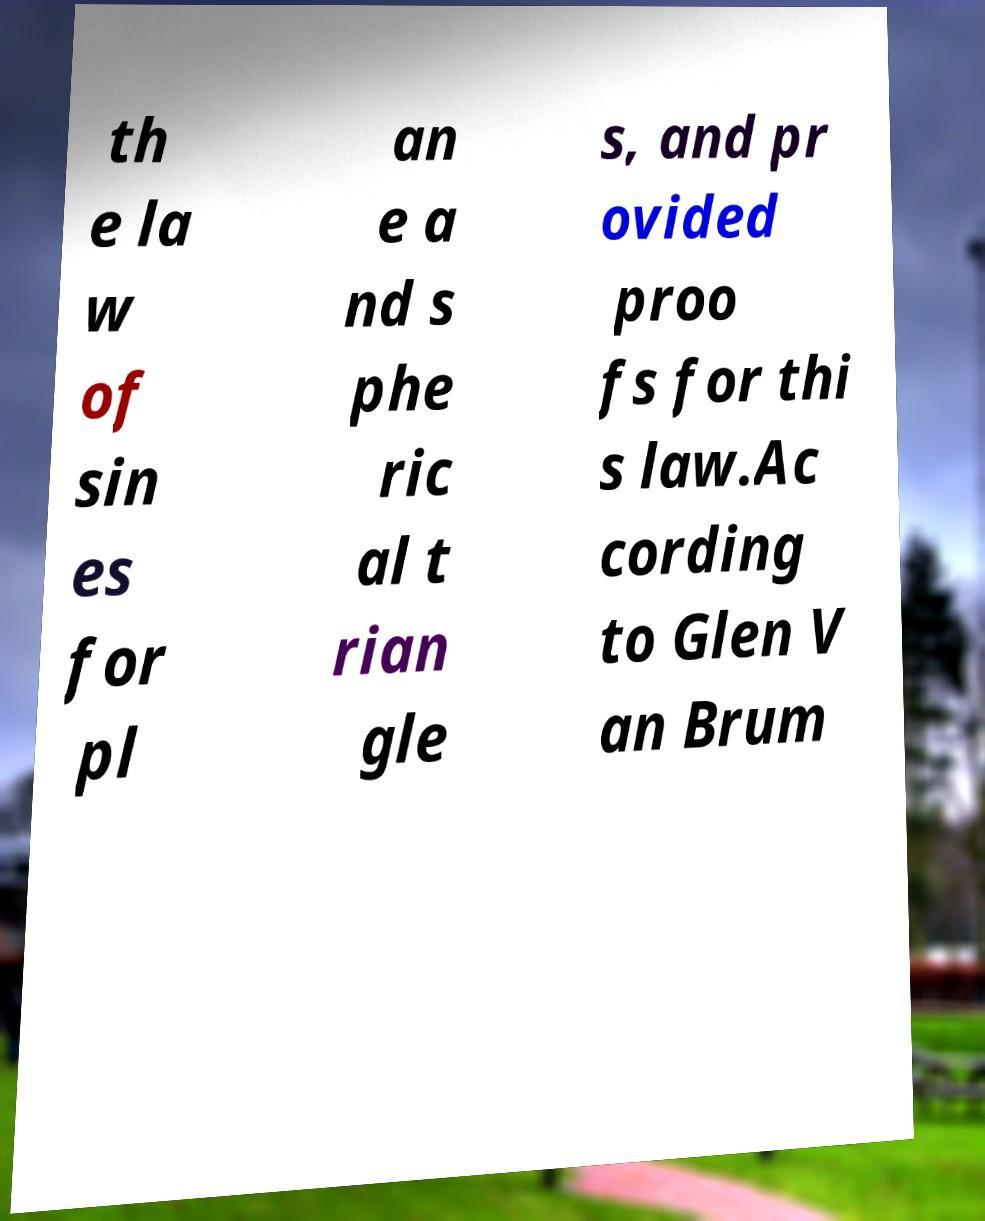Could you extract and type out the text from this image? th e la w of sin es for pl an e a nd s phe ric al t rian gle s, and pr ovided proo fs for thi s law.Ac cording to Glen V an Brum 